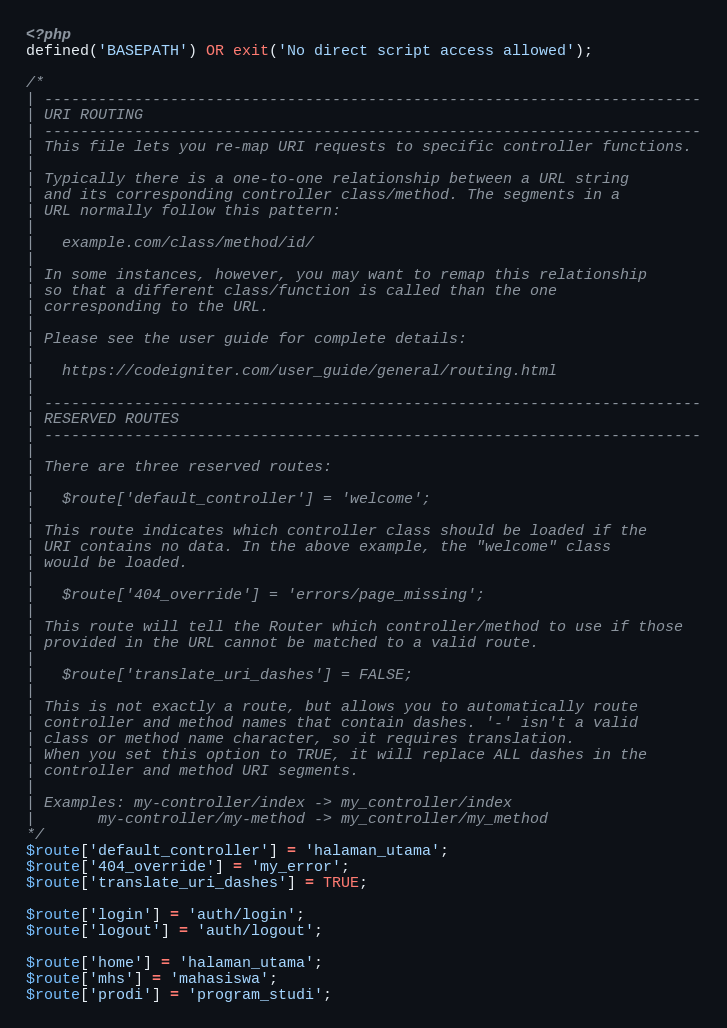<code> <loc_0><loc_0><loc_500><loc_500><_PHP_><?php
defined('BASEPATH') OR exit('No direct script access allowed');

/*
| -------------------------------------------------------------------------
| URI ROUTING
| -------------------------------------------------------------------------
| This file lets you re-map URI requests to specific controller functions.
|
| Typically there is a one-to-one relationship between a URL string
| and its corresponding controller class/method. The segments in a
| URL normally follow this pattern:
|
|	example.com/class/method/id/
|
| In some instances, however, you may want to remap this relationship
| so that a different class/function is called than the one
| corresponding to the URL.
|
| Please see the user guide for complete details:
|
|	https://codeigniter.com/user_guide/general/routing.html
|
| -------------------------------------------------------------------------
| RESERVED ROUTES
| -------------------------------------------------------------------------
|
| There are three reserved routes:
|
|	$route['default_controller'] = 'welcome';
|
| This route indicates which controller class should be loaded if the
| URI contains no data. In the above example, the "welcome" class
| would be loaded.
|
|	$route['404_override'] = 'errors/page_missing';
|
| This route will tell the Router which controller/method to use if those
| provided in the URL cannot be matched to a valid route.
|
|	$route['translate_uri_dashes'] = FALSE;
|
| This is not exactly a route, but allows you to automatically route
| controller and method names that contain dashes. '-' isn't a valid
| class or method name character, so it requires translation.
| When you set this option to TRUE, it will replace ALL dashes in the
| controller and method URI segments.
|
| Examples:	my-controller/index	-> my_controller/index
|		my-controller/my-method	-> my_controller/my_method
*/
$route['default_controller'] = 'halaman_utama';
$route['404_override'] = 'my_error';
$route['translate_uri_dashes'] = TRUE;

$route['login'] = 'auth/login';
$route['logout'] = 'auth/logout';

$route['home'] = 'halaman_utama';
$route['mhs'] = 'mahasiswa';
$route['prodi'] = 'program_studi';
</code> 